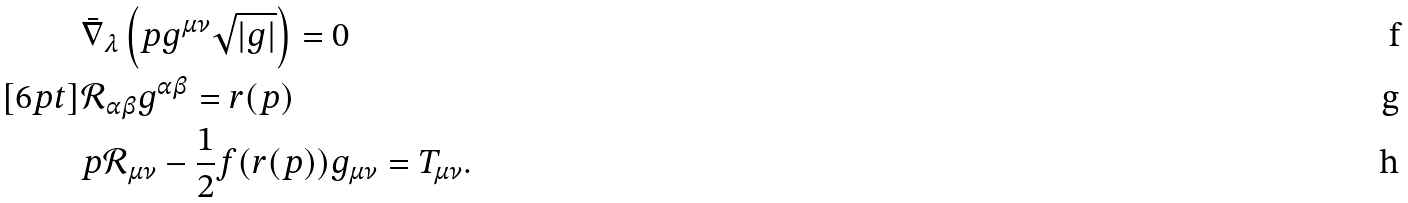<formula> <loc_0><loc_0><loc_500><loc_500>& \bar { \nabla } _ { \lambda } \left ( p g ^ { \mu \nu } \sqrt { | g | } \right ) = 0 \\ [ 6 p t ] & \mathcal { R } _ { \alpha \beta } g ^ { \alpha \beta } = r ( p ) \\ & p \mathcal { R } _ { \mu \nu } - \frac { 1 } { 2 } f ( r ( p ) ) g _ { \mu \nu } = T _ { \mu \nu } .</formula> 